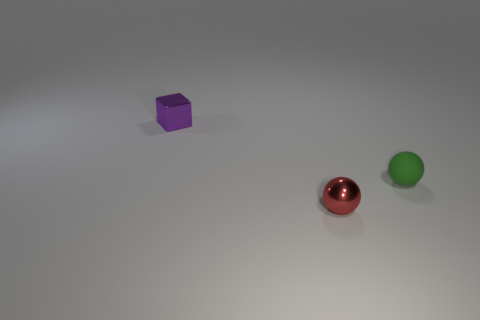Add 1 small red metal objects. How many objects exist? 4 Subtract all blocks. How many objects are left? 2 Add 2 red metallic objects. How many red metallic objects are left? 3 Add 1 tiny red spheres. How many tiny red spheres exist? 2 Subtract 0 yellow cubes. How many objects are left? 3 Subtract all tiny cyan matte balls. Subtract all small red spheres. How many objects are left? 2 